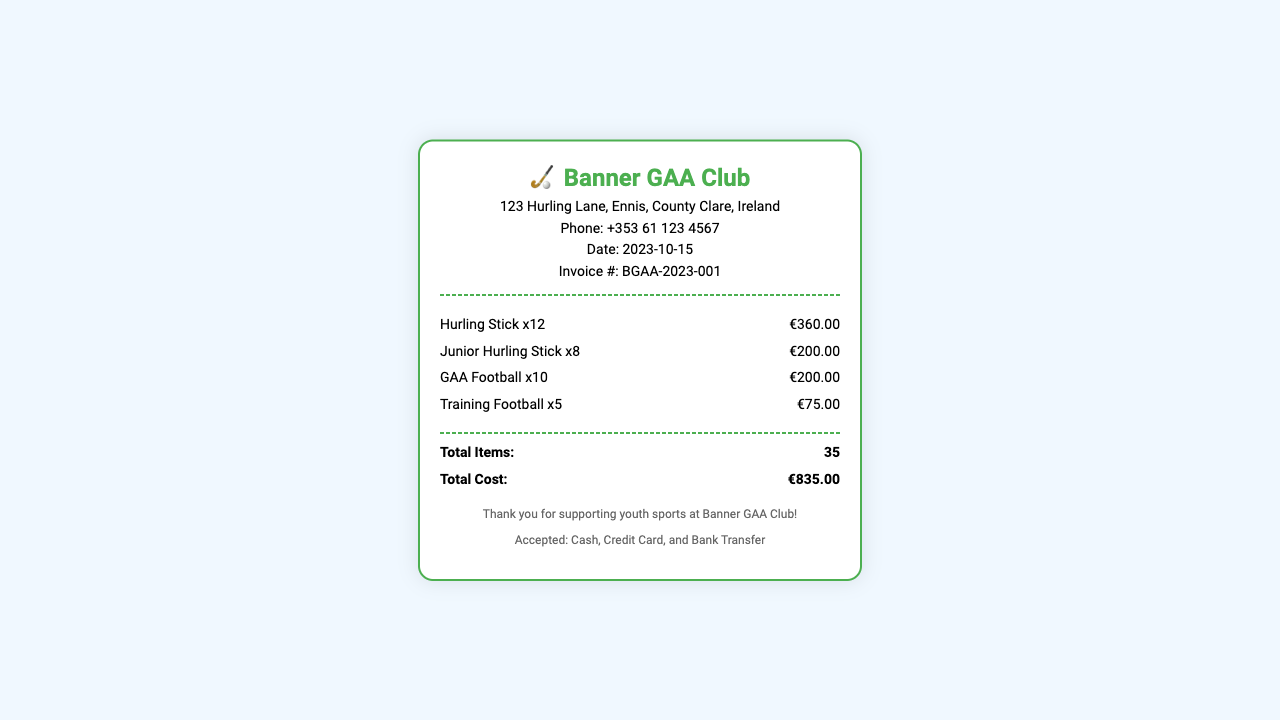What is the invoice number? The invoice number is provided in the header section of the receipt.
Answer: BGAA-2023-001 How many hurling sticks were purchased? The quantity of hurling sticks is detailed in the items list.
Answer: 12 What is the total cost of the purchase? The total cost is summed up in the summary section at the bottom of the receipt.
Answer: €835.00 What is the date of the receipt? The date of the receipt is indicated in the header section.
Answer: 2023-10-15 How many total items were purchased? The total number of items is listed in the summary section of the receipt.
Answer: 35 What is the price for the Junior Hurling Sticks? The price for Junior Hurling Sticks is shown next to their quantity in the items section.
Answer: €200.00 Which payment methods are accepted? Accepted payment methods are listed in the footer section of the receipt.
Answer: Cash, Credit Card, and Bank Transfer What is the address of the Banner GAA Club? The address is provided in the header section of the receipt.
Answer: 123 Hurling Lane, Ennis, County Clare, Ireland How many Training Footballs were purchased? The number of Training Footballs is specified in the items list.
Answer: 5 